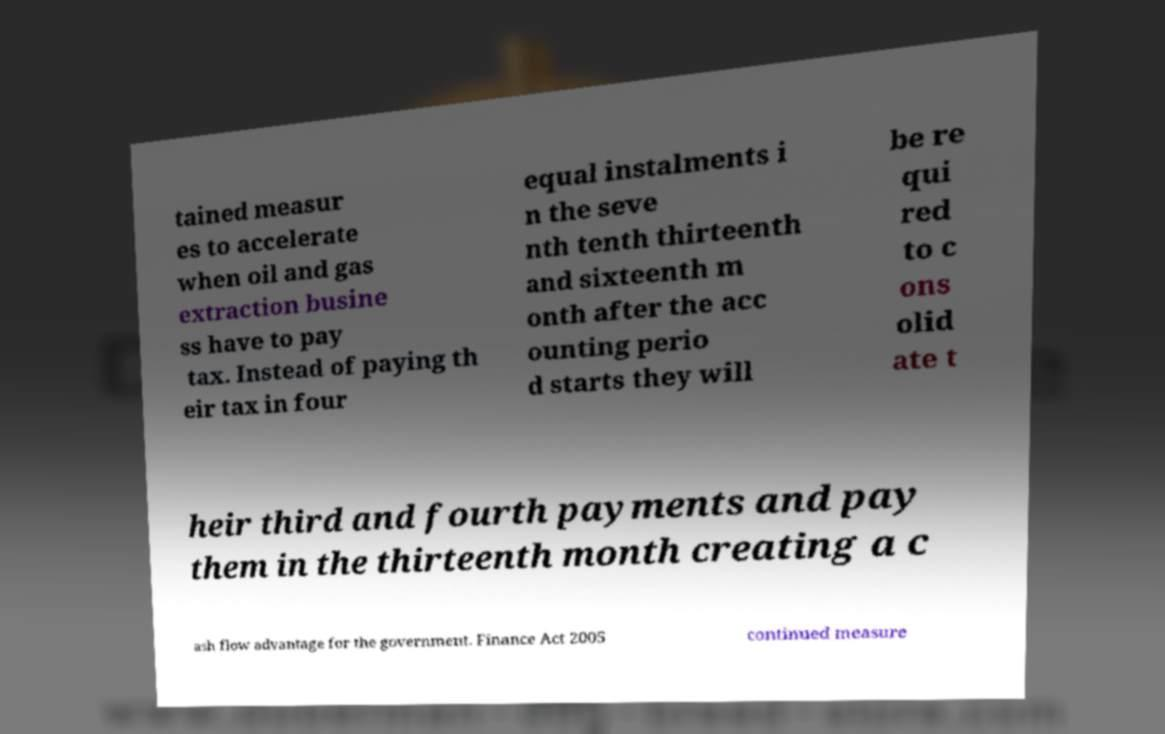Can you accurately transcribe the text from the provided image for me? tained measur es to accelerate when oil and gas extraction busine ss have to pay tax. Instead of paying th eir tax in four equal instalments i n the seve nth tenth thirteenth and sixteenth m onth after the acc ounting perio d starts they will be re qui red to c ons olid ate t heir third and fourth payments and pay them in the thirteenth month creating a c ash flow advantage for the government. Finance Act 2005 continued measure 